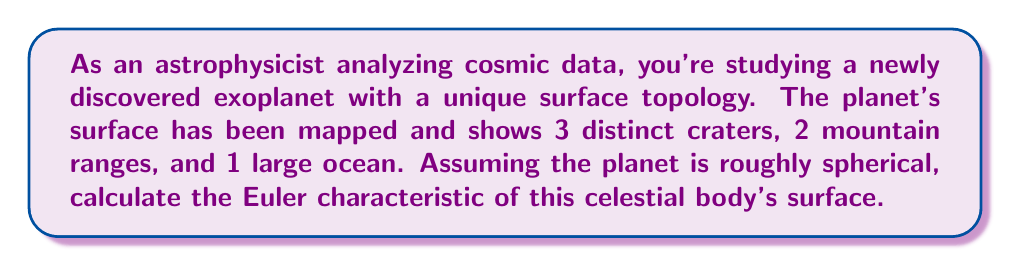Provide a solution to this math problem. To calculate the Euler characteristic of the exoplanet's surface, we'll use the formula:

$$\chi = V - E + F$$

Where:
$\chi$ is the Euler characteristic
$V$ is the number of vertices
$E$ is the number of edges
$F$ is the number of faces

For a sphere, which is the base shape of our planet, we know that:

1. $\chi_{sphere} = 2$

Now, we need to consider the topological features on the planet's surface:

2. Each crater is topologically equivalent to a puncture in the sphere. Each puncture decreases $\chi$ by 1.
   $$\Delta\chi_{craters} = -3$$

3. Each mountain range is topologically equivalent to a handle attached to the sphere. Each handle decreases $\chi$ by 2.
   $$\Delta\chi_{mountains} = -2 \times 2 = -4$$

4. The large ocean doesn't change the topology of the sphere, so it doesn't affect $\chi$.

Now, we can calculate the final Euler characteristic:

$$\begin{align*}
\chi_{final} &= \chi_{sphere} + \Delta\chi_{craters} + \Delta\chi_{mountains} \\
&= 2 + (-3) + (-4) \\
&= 2 - 3 - 4 \\
&= -5
\end{align*}$$

Therefore, the Euler characteristic of the exoplanet's surface is -5.
Answer: $\chi = -5$ 